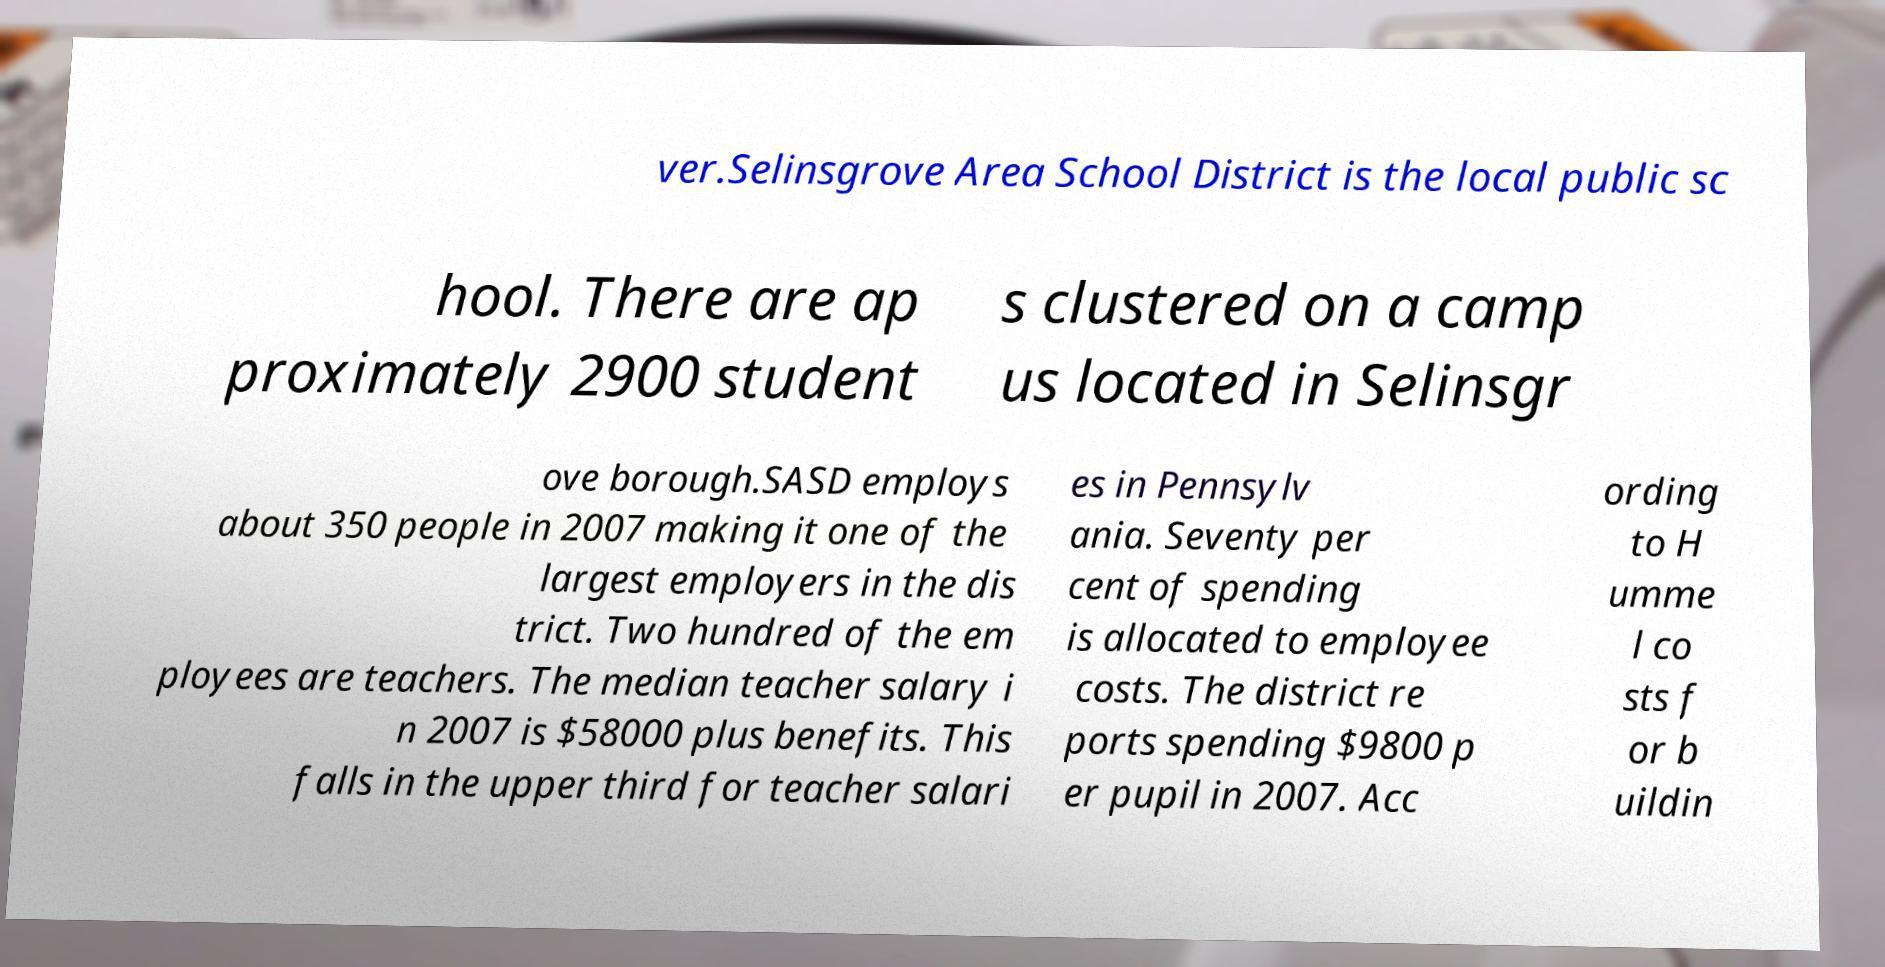Please read and relay the text visible in this image. What does it say? ver.Selinsgrove Area School District is the local public sc hool. There are ap proximately 2900 student s clustered on a camp us located in Selinsgr ove borough.SASD employs about 350 people in 2007 making it one of the largest employers in the dis trict. Two hundred of the em ployees are teachers. The median teacher salary i n 2007 is $58000 plus benefits. This falls in the upper third for teacher salari es in Pennsylv ania. Seventy per cent of spending is allocated to employee costs. The district re ports spending $9800 p er pupil in 2007. Acc ording to H umme l co sts f or b uildin 